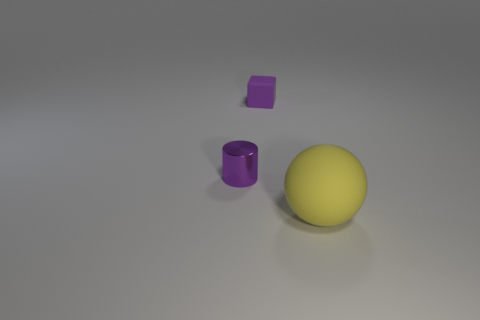Add 1 large purple blocks. How many objects exist? 4 Subtract all blocks. How many objects are left? 2 Subtract 0 gray balls. How many objects are left? 3 Subtract all tiny brown balls. Subtract all tiny purple metal cylinders. How many objects are left? 2 Add 3 matte things. How many matte things are left? 5 Add 2 tiny blue matte things. How many tiny blue matte things exist? 2 